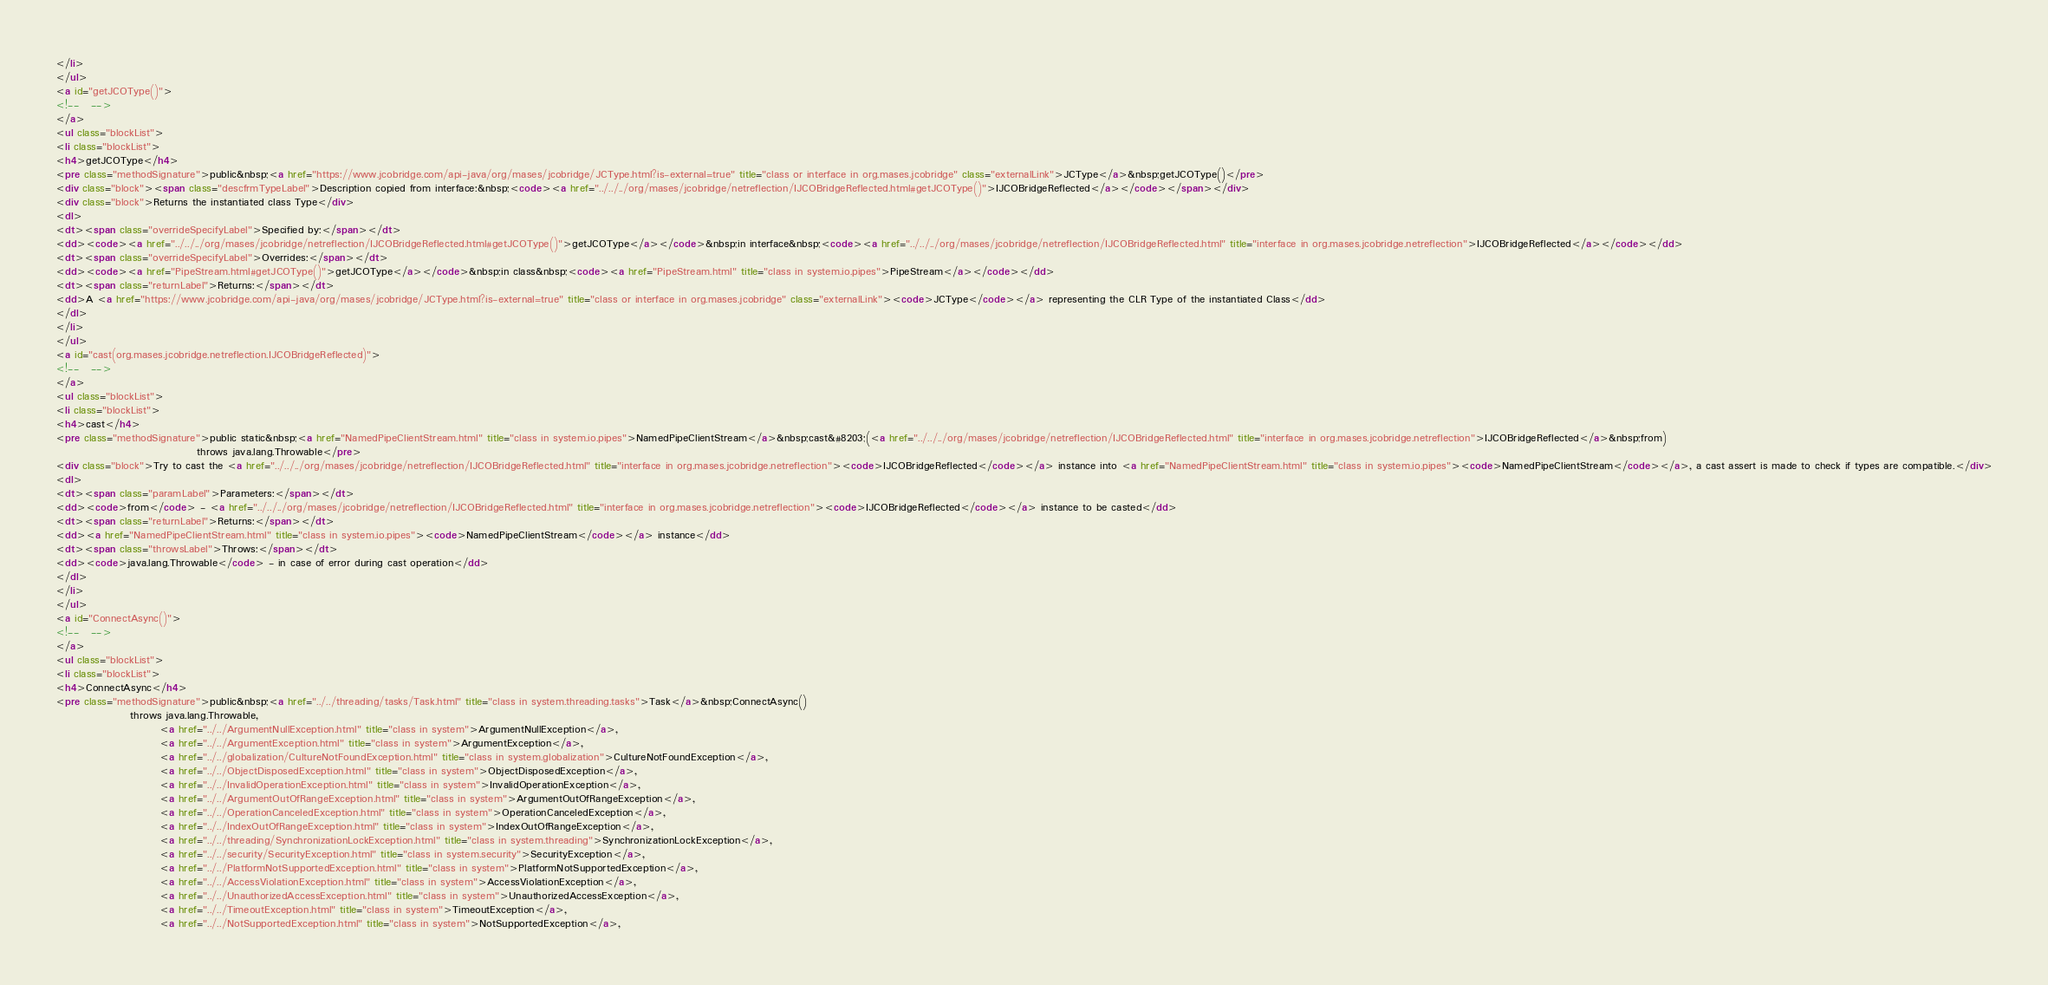Convert code to text. <code><loc_0><loc_0><loc_500><loc_500><_HTML_></li>
</ul>
<a id="getJCOType()">
<!--   -->
</a>
<ul class="blockList">
<li class="blockList">
<h4>getJCOType</h4>
<pre class="methodSignature">public&nbsp;<a href="https://www.jcobridge.com/api-java/org/mases/jcobridge/JCType.html?is-external=true" title="class or interface in org.mases.jcobridge" class="externalLink">JCType</a>&nbsp;getJCOType()</pre>
<div class="block"><span class="descfrmTypeLabel">Description copied from interface:&nbsp;<code><a href="../../../org/mases/jcobridge/netreflection/IJCOBridgeReflected.html#getJCOType()">IJCOBridgeReflected</a></code></span></div>
<div class="block">Returns the instantiated class Type</div>
<dl>
<dt><span class="overrideSpecifyLabel">Specified by:</span></dt>
<dd><code><a href="../../../org/mases/jcobridge/netreflection/IJCOBridgeReflected.html#getJCOType()">getJCOType</a></code>&nbsp;in interface&nbsp;<code><a href="../../../org/mases/jcobridge/netreflection/IJCOBridgeReflected.html" title="interface in org.mases.jcobridge.netreflection">IJCOBridgeReflected</a></code></dd>
<dt><span class="overrideSpecifyLabel">Overrides:</span></dt>
<dd><code><a href="PipeStream.html#getJCOType()">getJCOType</a></code>&nbsp;in class&nbsp;<code><a href="PipeStream.html" title="class in system.io.pipes">PipeStream</a></code></dd>
<dt><span class="returnLabel">Returns:</span></dt>
<dd>A <a href="https://www.jcobridge.com/api-java/org/mases/jcobridge/JCType.html?is-external=true" title="class or interface in org.mases.jcobridge" class="externalLink"><code>JCType</code></a> representing the CLR Type of the instantiated Class</dd>
</dl>
</li>
</ul>
<a id="cast(org.mases.jcobridge.netreflection.IJCOBridgeReflected)">
<!--   -->
</a>
<ul class="blockList">
<li class="blockList">
<h4>cast</h4>
<pre class="methodSignature">public static&nbsp;<a href="NamedPipeClientStream.html" title="class in system.io.pipes">NamedPipeClientStream</a>&nbsp;cast&#8203;(<a href="../../../org/mases/jcobridge/netreflection/IJCOBridgeReflected.html" title="interface in org.mases.jcobridge.netreflection">IJCOBridgeReflected</a>&nbsp;from)
                                  throws java.lang.Throwable</pre>
<div class="block">Try to cast the <a href="../../../org/mases/jcobridge/netreflection/IJCOBridgeReflected.html" title="interface in org.mases.jcobridge.netreflection"><code>IJCOBridgeReflected</code></a> instance into <a href="NamedPipeClientStream.html" title="class in system.io.pipes"><code>NamedPipeClientStream</code></a>, a cast assert is made to check if types are compatible.</div>
<dl>
<dt><span class="paramLabel">Parameters:</span></dt>
<dd><code>from</code> - <a href="../../../org/mases/jcobridge/netreflection/IJCOBridgeReflected.html" title="interface in org.mases.jcobridge.netreflection"><code>IJCOBridgeReflected</code></a> instance to be casted</dd>
<dt><span class="returnLabel">Returns:</span></dt>
<dd><a href="NamedPipeClientStream.html" title="class in system.io.pipes"><code>NamedPipeClientStream</code></a> instance</dd>
<dt><span class="throwsLabel">Throws:</span></dt>
<dd><code>java.lang.Throwable</code> - in case of error during cast operation</dd>
</dl>
</li>
</ul>
<a id="ConnectAsync()">
<!--   -->
</a>
<ul class="blockList">
<li class="blockList">
<h4>ConnectAsync</h4>
<pre class="methodSignature">public&nbsp;<a href="../../threading/tasks/Task.html" title="class in system.threading.tasks">Task</a>&nbsp;ConnectAsync()
                  throws java.lang.Throwable,
                         <a href="../../ArgumentNullException.html" title="class in system">ArgumentNullException</a>,
                         <a href="../../ArgumentException.html" title="class in system">ArgumentException</a>,
                         <a href="../../globalization/CultureNotFoundException.html" title="class in system.globalization">CultureNotFoundException</a>,
                         <a href="../../ObjectDisposedException.html" title="class in system">ObjectDisposedException</a>,
                         <a href="../../InvalidOperationException.html" title="class in system">InvalidOperationException</a>,
                         <a href="../../ArgumentOutOfRangeException.html" title="class in system">ArgumentOutOfRangeException</a>,
                         <a href="../../OperationCanceledException.html" title="class in system">OperationCanceledException</a>,
                         <a href="../../IndexOutOfRangeException.html" title="class in system">IndexOutOfRangeException</a>,
                         <a href="../../threading/SynchronizationLockException.html" title="class in system.threading">SynchronizationLockException</a>,
                         <a href="../../security/SecurityException.html" title="class in system.security">SecurityException</a>,
                         <a href="../../PlatformNotSupportedException.html" title="class in system">PlatformNotSupportedException</a>,
                         <a href="../../AccessViolationException.html" title="class in system">AccessViolationException</a>,
                         <a href="../../UnauthorizedAccessException.html" title="class in system">UnauthorizedAccessException</a>,
                         <a href="../../TimeoutException.html" title="class in system">TimeoutException</a>,
                         <a href="../../NotSupportedException.html" title="class in system">NotSupportedException</a>,</code> 